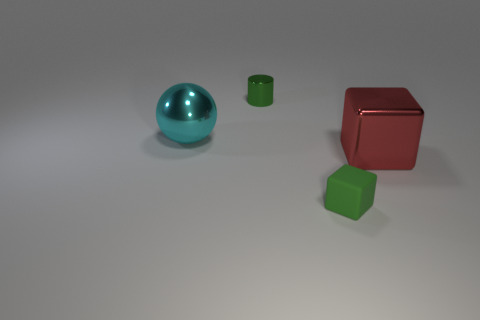Add 2 small things. How many objects exist? 6 Subtract all cylinders. How many objects are left? 3 Subtract all tiny green rubber cubes. Subtract all brown cubes. How many objects are left? 3 Add 1 red metal objects. How many red metal objects are left? 2 Add 1 green objects. How many green objects exist? 3 Subtract 0 red balls. How many objects are left? 4 